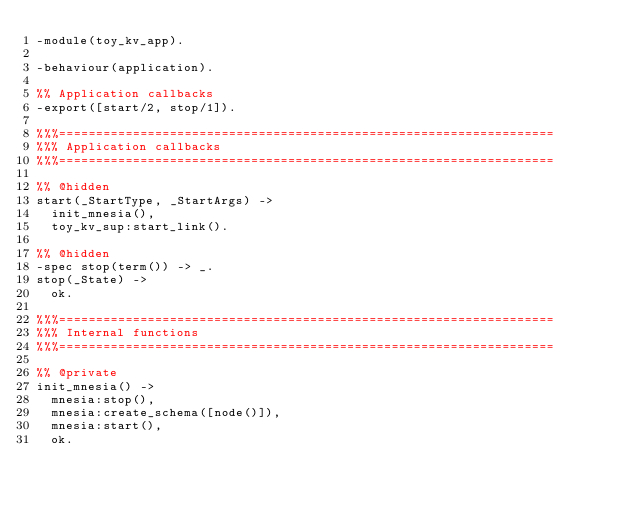<code> <loc_0><loc_0><loc_500><loc_500><_Erlang_>-module(toy_kv_app).

-behaviour(application).

%% Application callbacks
-export([start/2, stop/1]).

%%%===================================================================
%%% Application callbacks
%%%===================================================================

%% @hidden
start(_StartType, _StartArgs) ->
  init_mnesia(),
  toy_kv_sup:start_link().

%% @hidden
-spec stop(term()) -> _.
stop(_State) ->
  ok.

%%%===================================================================
%%% Internal functions
%%%===================================================================

%% @private
init_mnesia() ->
  mnesia:stop(),
  mnesia:create_schema([node()]),
  mnesia:start(),
  ok.
</code> 